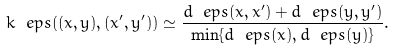Convert formula to latex. <formula><loc_0><loc_0><loc_500><loc_500>k _ { \ } e p s ( ( x , y ) , ( x ^ { \prime } , y ^ { \prime } ) ) \simeq \frac { d _ { \ } e p s ( x , x ^ { \prime } ) + d _ { \ } e p s ( y , y ^ { \prime } ) } { \min \{ d _ { \ } e p s ( x ) , d _ { \ } e p s ( y ) \} } .</formula> 